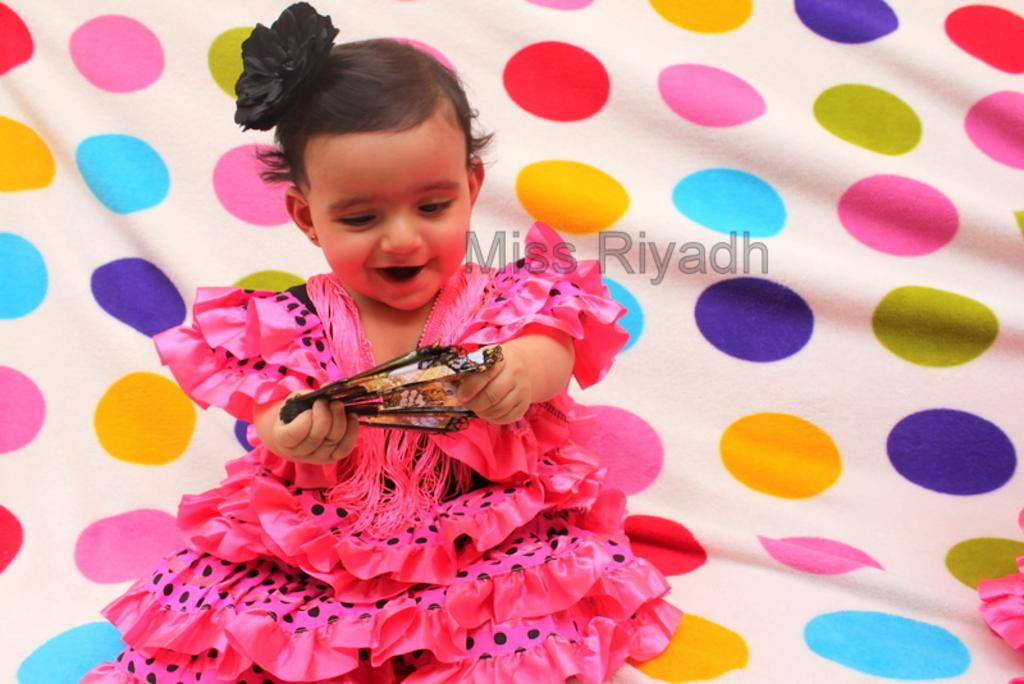Who is the main subject in the image? There is a baby girl in the image. What is the baby girl doing? The baby girl is smiling. What is the baby girl holding in the image? The baby girl is holding an object. Can you describe the text in the middle of the image? There is some text in the middle of the image. What type of judge is present in the image? There is no judge present in the image; it features a baby girl. What kind of apparatus is being used by the baby girl in the image? There is no apparatus visible in the image; the baby girl is holding an object, but it is not specified as an apparatus. 